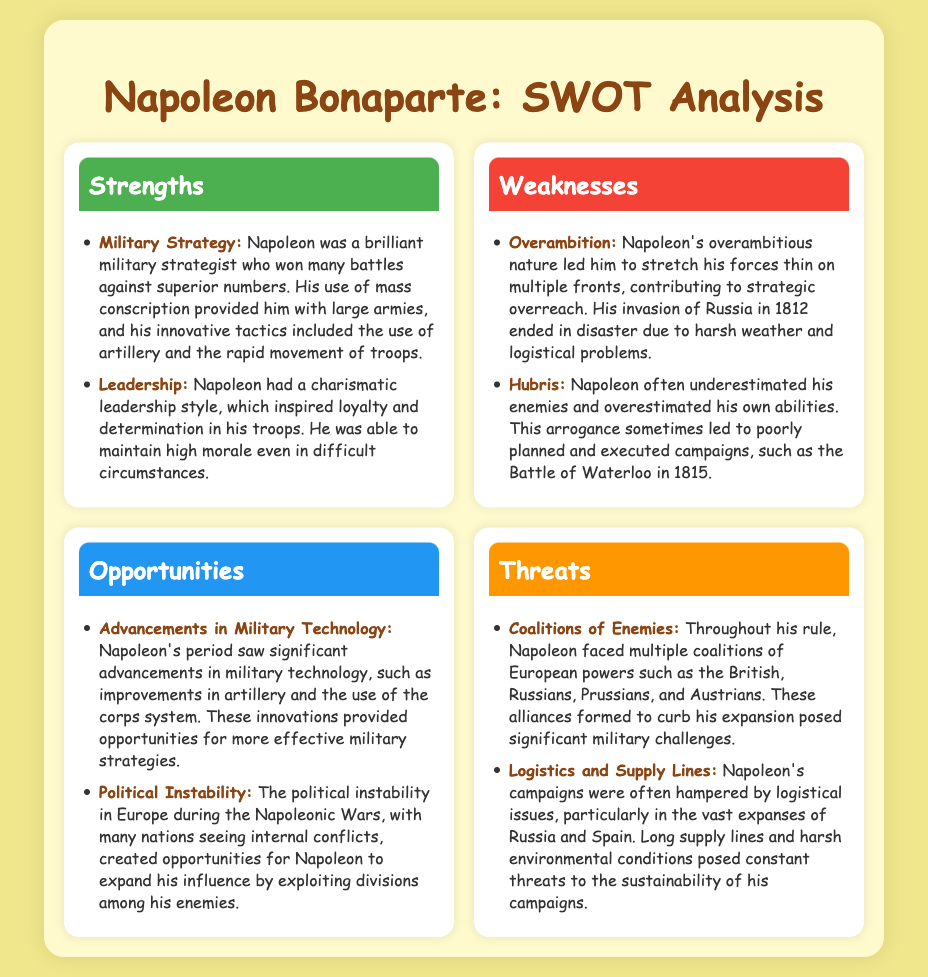What is one of Napoleon's strengths as a military leader? The document lists multiple strengths of Napoleon, including his military strategy and leadership skills.
Answer: Military Strategy What specific weakness is associated with Napoleon's invasion of Russia? The document mentions that his invasion of Russia ended in disaster due to harsh weather and logistical problems.
Answer: Overambition Which opportunity did Napoleon have due to the political state of Europe? The document states that political instability in Europe created opportunities for Napoleon to expand his influence.
Answer: Political Instability What was a significant threat that Napoleon faced during his campaigns? The document notes that Napoleon faced coalitions of European powers which posed significant military challenges.
Answer: Coalitions of Enemies What innovative military tactic did Napoleon use? One of the strengths listed in the document is Napoleon's innovative tactics, including the use of artillery.
Answer: Artillery In what year did the Battle of Waterloo occur? The document includes the year related to Napoleon's campaign failures, specifically citing the Battle of Waterloo.
Answer: 1815 What did Napoleon's charismatic leadership help inspire in his troops? The document indicates that his leadership inspired loyalty and determination in his troops.
Answer: Loyalty How did Napoleon's ambitions affect his strategy? According to the document, Napoleon's overambition contributed to his strategic overreach.
Answer: Strategic Overreach What type of problems affected Napoleon's military campaigns? The document discusses logistical issues affecting Napoleon's campaigns, particularly in harsh environments.
Answer: Logistics and Supply Lines 